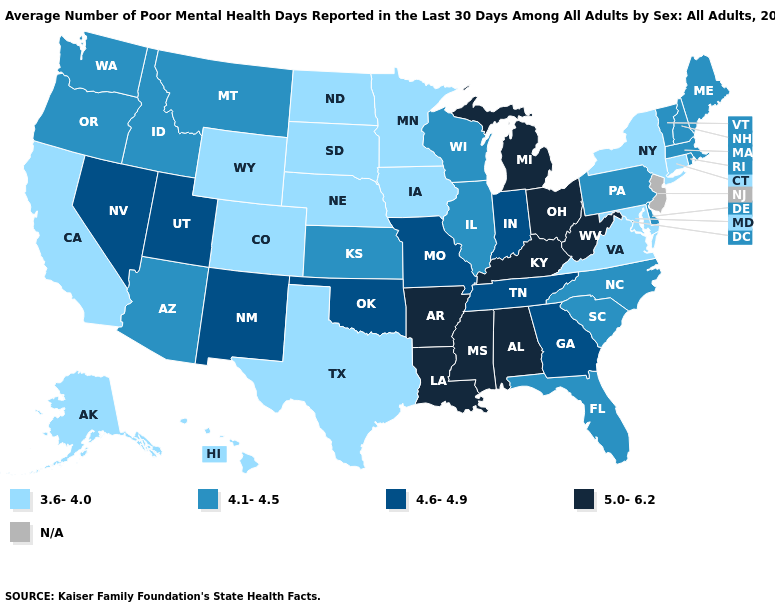Which states have the lowest value in the South?
Be succinct. Maryland, Texas, Virginia. Does Pennsylvania have the highest value in the Northeast?
Be succinct. Yes. What is the highest value in the USA?
Answer briefly. 5.0-6.2. What is the value of West Virginia?
Answer briefly. 5.0-6.2. What is the value of Virginia?
Short answer required. 3.6-4.0. Among the states that border Iowa , which have the highest value?
Short answer required. Missouri. Does the first symbol in the legend represent the smallest category?
Keep it brief. Yes. Name the states that have a value in the range 5.0-6.2?
Write a very short answer. Alabama, Arkansas, Kentucky, Louisiana, Michigan, Mississippi, Ohio, West Virginia. Does Michigan have the lowest value in the USA?
Quick response, please. No. Name the states that have a value in the range 5.0-6.2?
Write a very short answer. Alabama, Arkansas, Kentucky, Louisiana, Michigan, Mississippi, Ohio, West Virginia. Does the first symbol in the legend represent the smallest category?
Write a very short answer. Yes. How many symbols are there in the legend?
Answer briefly. 5. Name the states that have a value in the range N/A?
Write a very short answer. New Jersey. Does Michigan have the highest value in the USA?
Be succinct. Yes. 